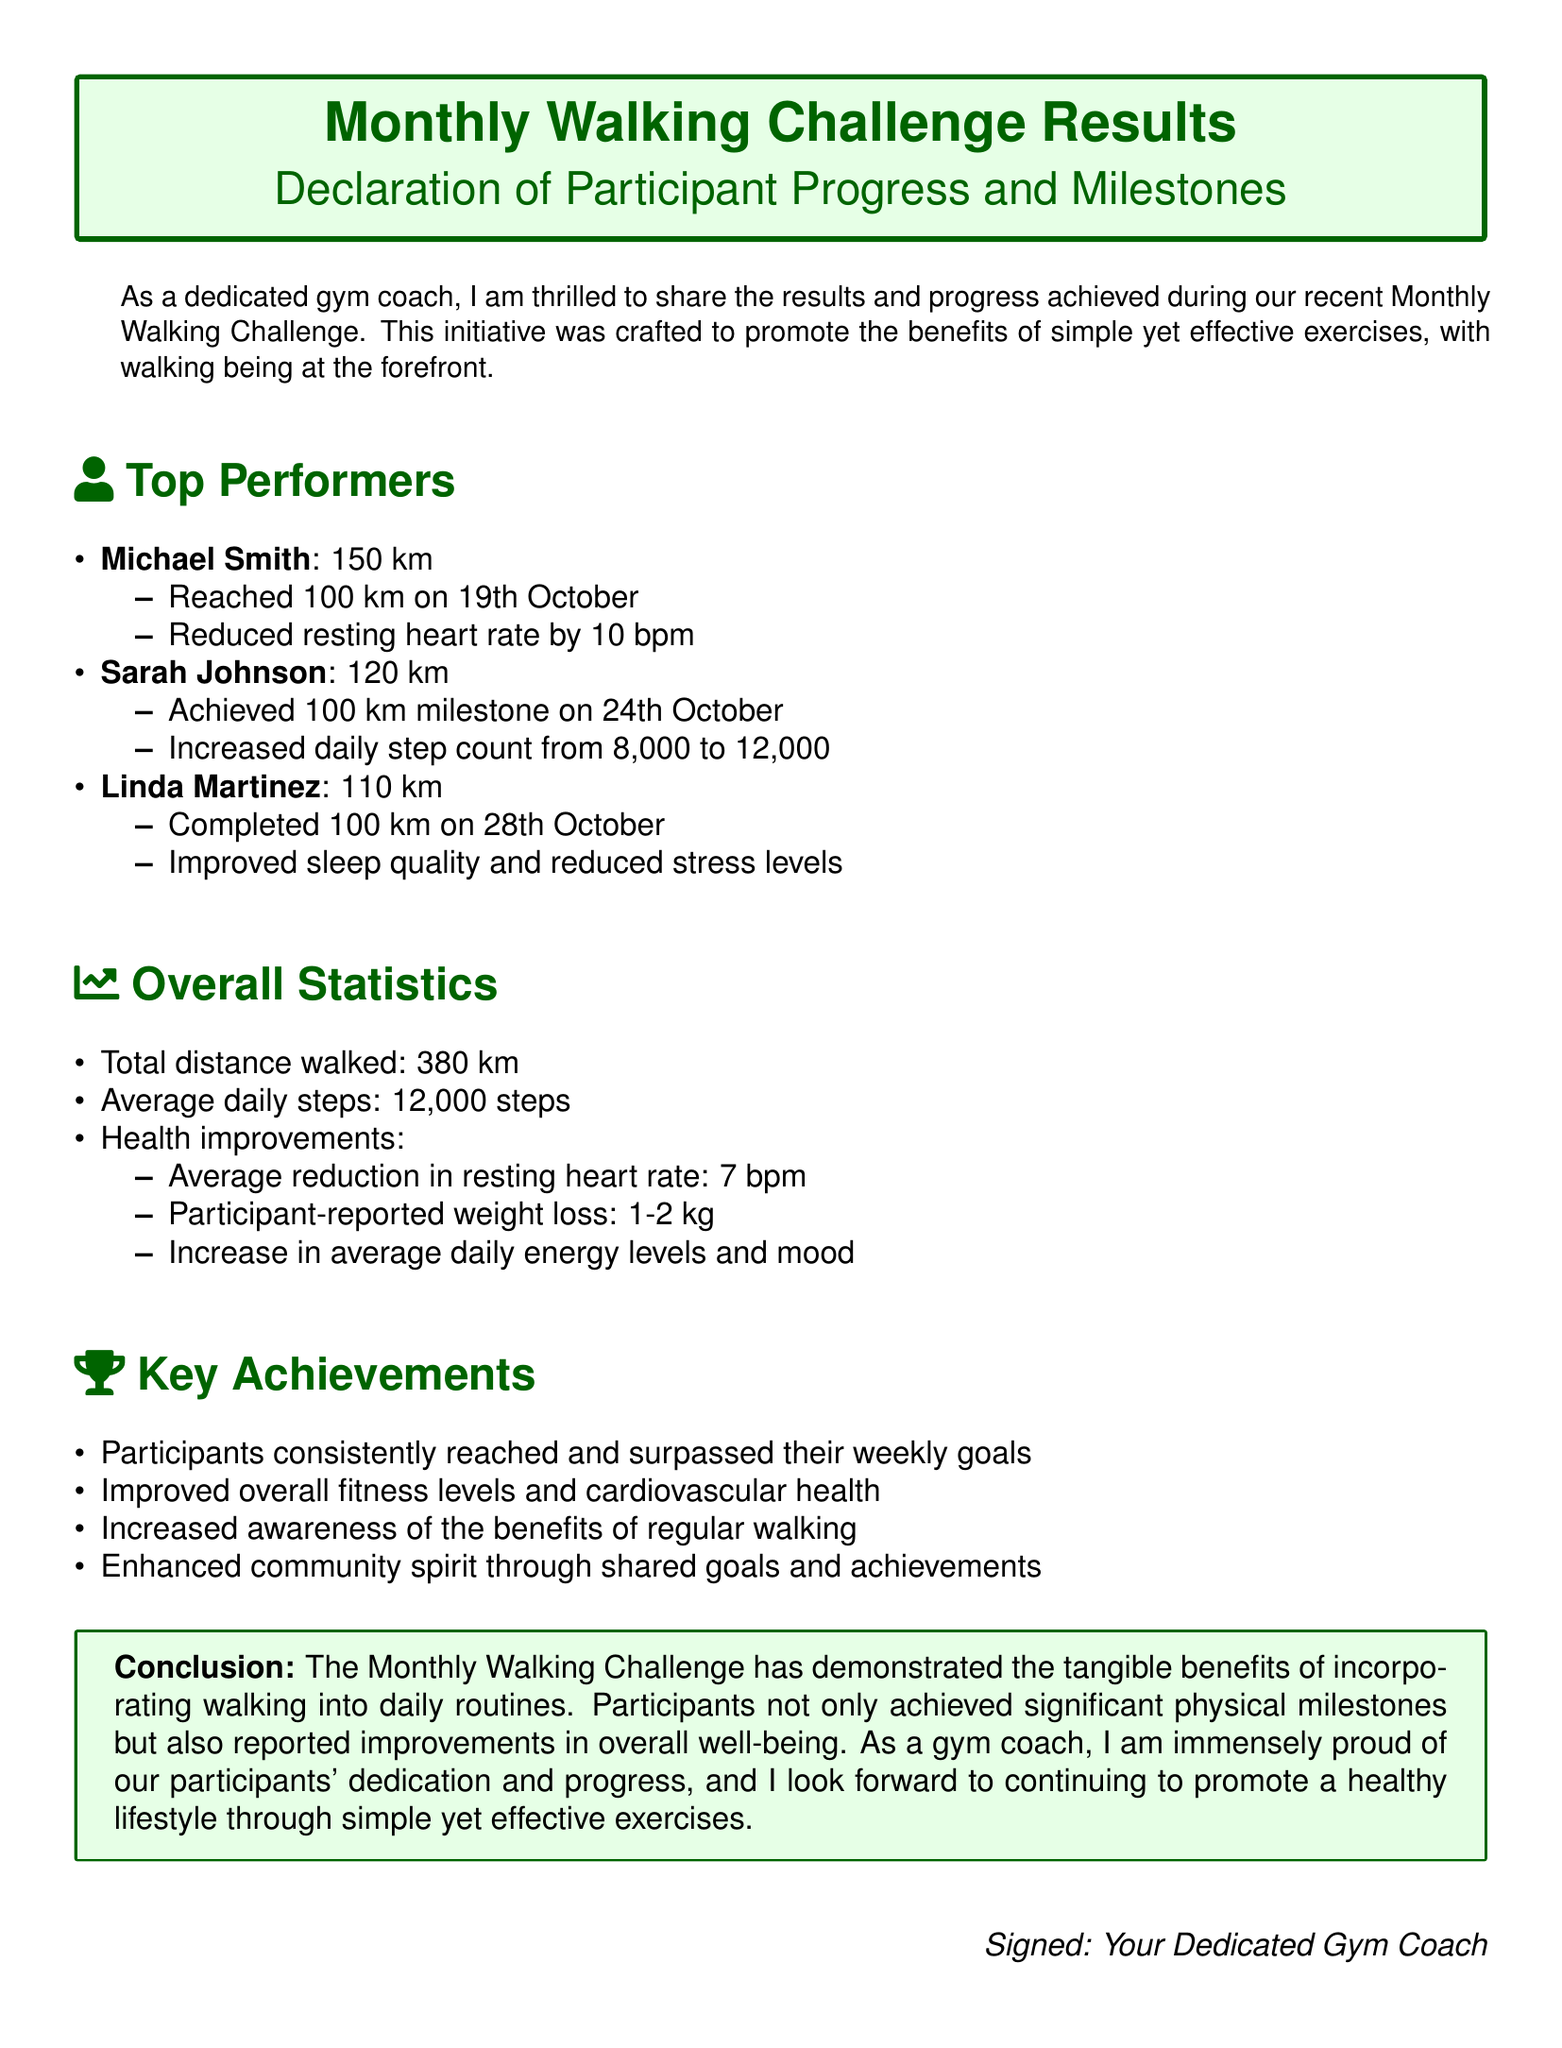What is the total distance walked during the challenge? The total distance walked is mentioned in the overall statistics section of the document, which states it is 380 km.
Answer: 380 km Who achieved the milestone of 100 km first? The document lists participants along with their milestones, indicating that Michael Smith reached 100 km on 19th October.
Answer: Michael Smith What was the average daily step count during the challenge? The average daily steps are highlighted in the overall statistics section, stating it was 12,000 steps.
Answer: 12,000 steps How many kilometers did Linda Martinez complete? The document states that Linda Martinez completed a total of 110 km during the challenge.
Answer: 110 km What significant health improvement was reported on average? The health improvements include a reduction in resting heart rate, which was averaged at 7 bpm.
Answer: 7 bpm On what date did Sarah Johnson achieve 100 km? The document specifies that Sarah Johnson reached her 100 km milestone on 24th October.
Answer: 24th October What conclusion is drawn about the Monthly Walking Challenge? The conclusion emphasizes that participants achieved significant physical milestones and improvements in overall well-being.
Answer: Significant physical milestones and improvements in overall well-being What was a key achievement noted in the document? The document highlights that participants consistently reached and surpassed their weekly goals as one of the key achievements.
Answer: Consistently reached and surpassed their weekly goals 